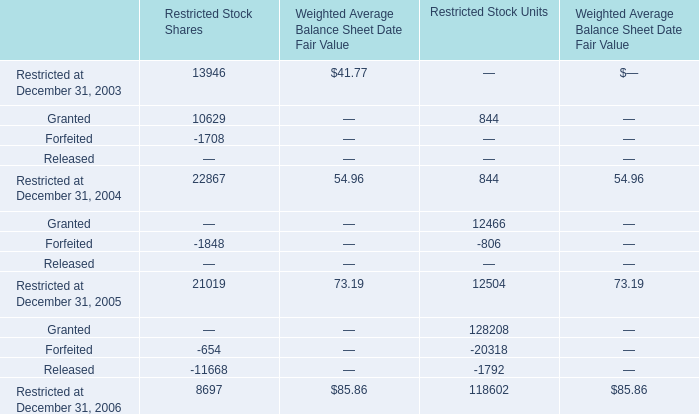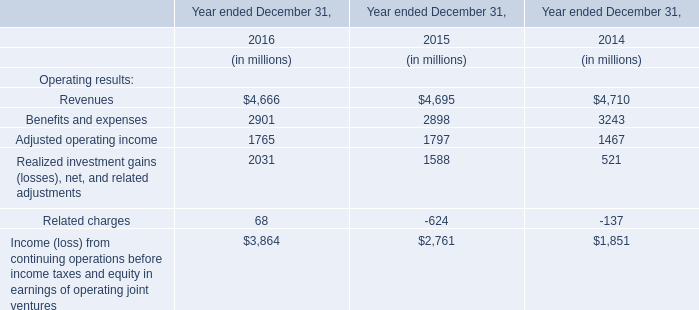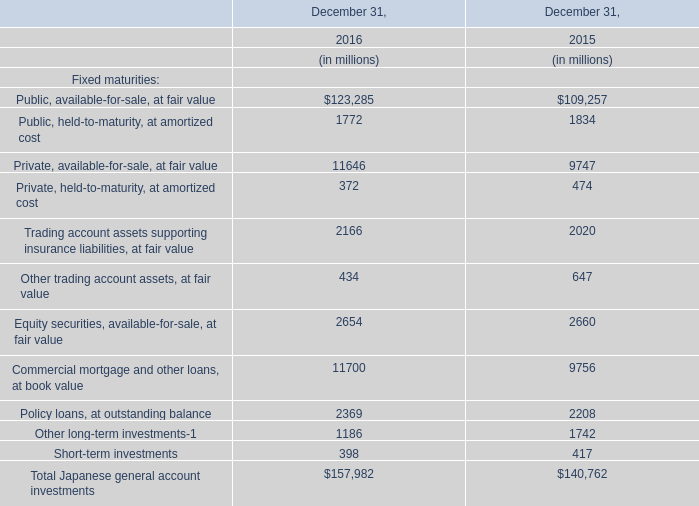Which year is Granted for Restricted Stock Units the most? 
Answer: 2005. 